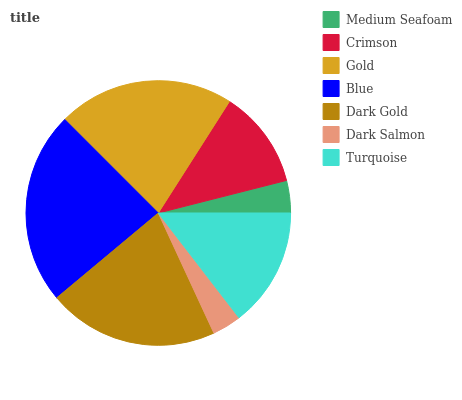Is Dark Salmon the minimum?
Answer yes or no. Yes. Is Blue the maximum?
Answer yes or no. Yes. Is Crimson the minimum?
Answer yes or no. No. Is Crimson the maximum?
Answer yes or no. No. Is Crimson greater than Medium Seafoam?
Answer yes or no. Yes. Is Medium Seafoam less than Crimson?
Answer yes or no. Yes. Is Medium Seafoam greater than Crimson?
Answer yes or no. No. Is Crimson less than Medium Seafoam?
Answer yes or no. No. Is Turquoise the high median?
Answer yes or no. Yes. Is Turquoise the low median?
Answer yes or no. Yes. Is Gold the high median?
Answer yes or no. No. Is Crimson the low median?
Answer yes or no. No. 